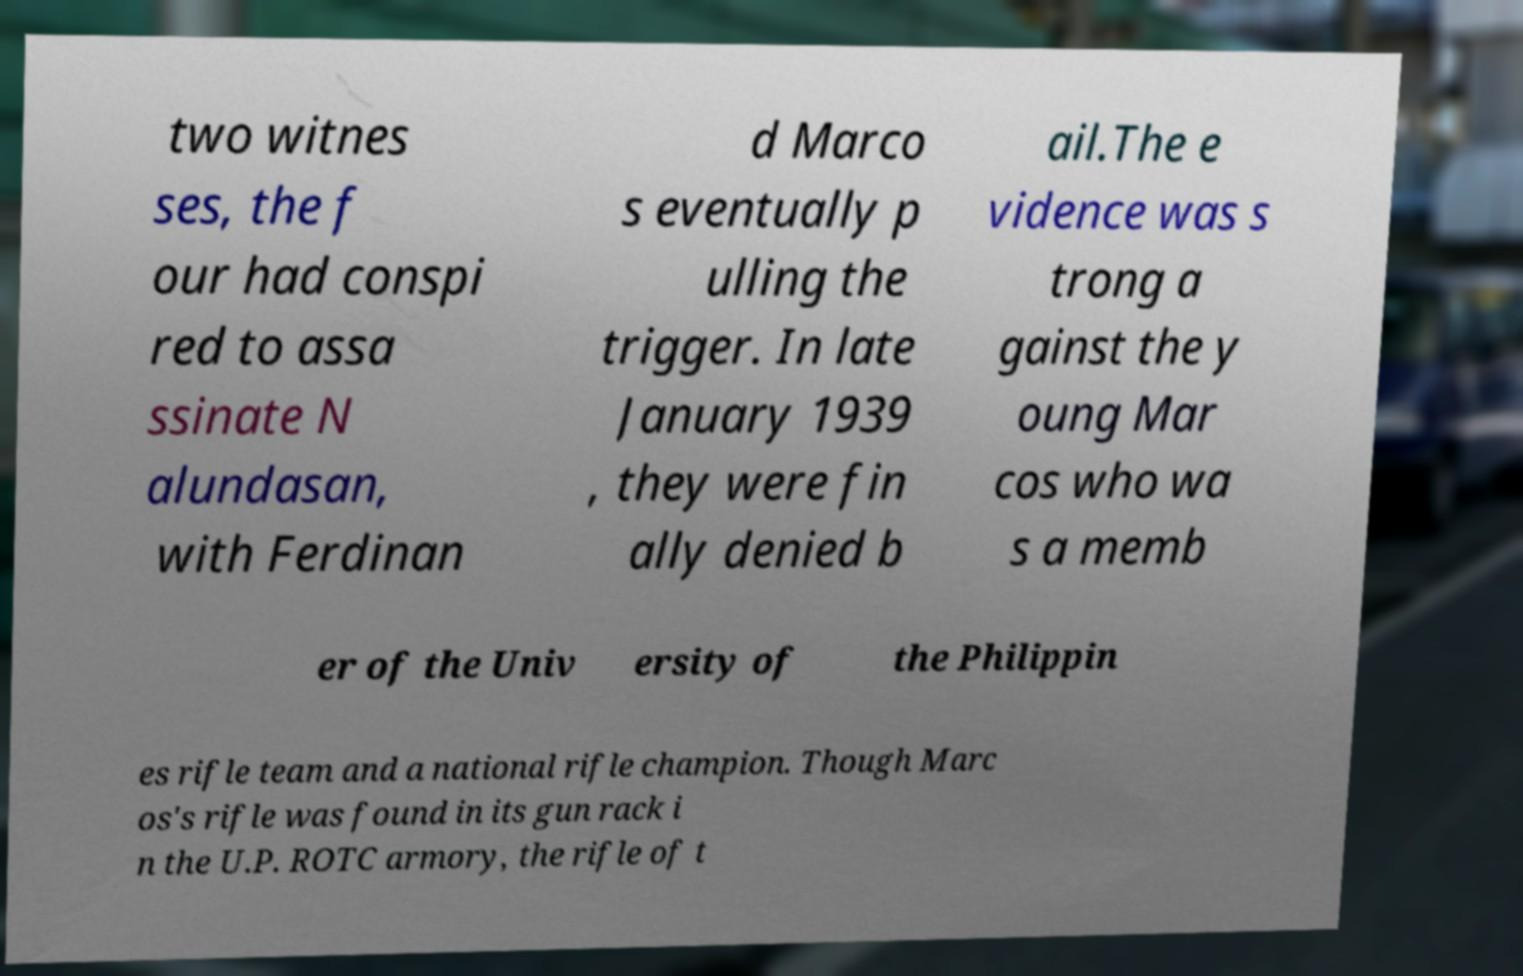There's text embedded in this image that I need extracted. Can you transcribe it verbatim? two witnes ses, the f our had conspi red to assa ssinate N alundasan, with Ferdinan d Marco s eventually p ulling the trigger. In late January 1939 , they were fin ally denied b ail.The e vidence was s trong a gainst the y oung Mar cos who wa s a memb er of the Univ ersity of the Philippin es rifle team and a national rifle champion. Though Marc os's rifle was found in its gun rack i n the U.P. ROTC armory, the rifle of t 